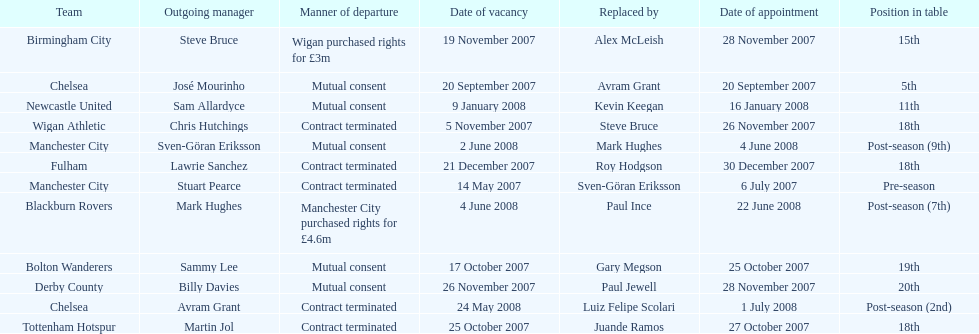How many teams had a manner of departure due to there contract being terminated? 5. 